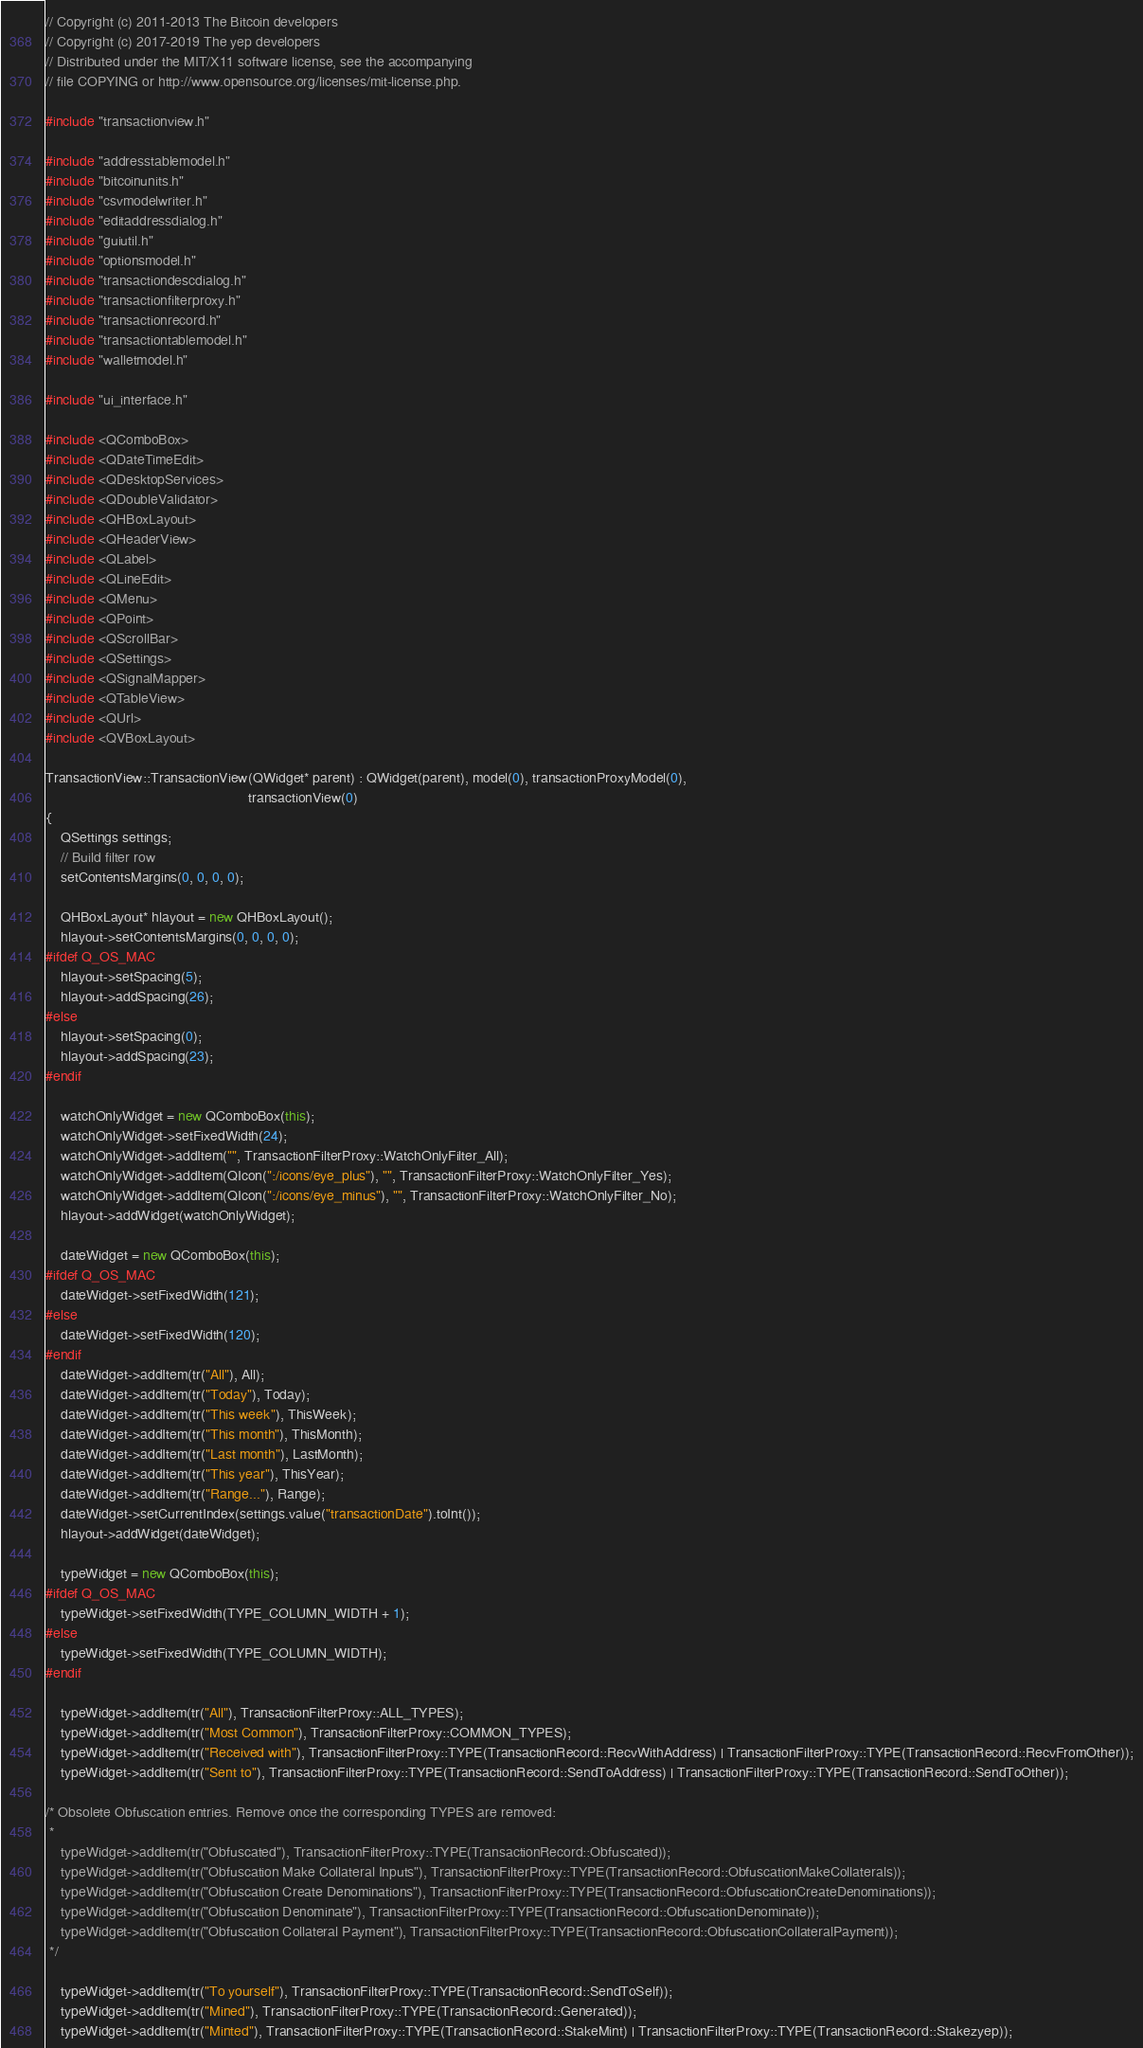<code> <loc_0><loc_0><loc_500><loc_500><_C++_>// Copyright (c) 2011-2013 The Bitcoin developers
// Copyright (c) 2017-2019 The yep developers
// Distributed under the MIT/X11 software license, see the accompanying
// file COPYING or http://www.opensource.org/licenses/mit-license.php.

#include "transactionview.h"

#include "addresstablemodel.h"
#include "bitcoinunits.h"
#include "csvmodelwriter.h"
#include "editaddressdialog.h"
#include "guiutil.h"
#include "optionsmodel.h"
#include "transactiondescdialog.h"
#include "transactionfilterproxy.h"
#include "transactionrecord.h"
#include "transactiontablemodel.h"
#include "walletmodel.h"

#include "ui_interface.h"

#include <QComboBox>
#include <QDateTimeEdit>
#include <QDesktopServices>
#include <QDoubleValidator>
#include <QHBoxLayout>
#include <QHeaderView>
#include <QLabel>
#include <QLineEdit>
#include <QMenu>
#include <QPoint>
#include <QScrollBar>
#include <QSettings>
#include <QSignalMapper>
#include <QTableView>
#include <QUrl>
#include <QVBoxLayout>

TransactionView::TransactionView(QWidget* parent) : QWidget(parent), model(0), transactionProxyModel(0),
                                                    transactionView(0)
{
    QSettings settings;
    // Build filter row
    setContentsMargins(0, 0, 0, 0);

    QHBoxLayout* hlayout = new QHBoxLayout();
    hlayout->setContentsMargins(0, 0, 0, 0);
#ifdef Q_OS_MAC
    hlayout->setSpacing(5);
    hlayout->addSpacing(26);
#else
    hlayout->setSpacing(0);
    hlayout->addSpacing(23);
#endif

    watchOnlyWidget = new QComboBox(this);
    watchOnlyWidget->setFixedWidth(24);
    watchOnlyWidget->addItem("", TransactionFilterProxy::WatchOnlyFilter_All);
    watchOnlyWidget->addItem(QIcon(":/icons/eye_plus"), "", TransactionFilterProxy::WatchOnlyFilter_Yes);
    watchOnlyWidget->addItem(QIcon(":/icons/eye_minus"), "", TransactionFilterProxy::WatchOnlyFilter_No);
    hlayout->addWidget(watchOnlyWidget);

    dateWidget = new QComboBox(this);
#ifdef Q_OS_MAC
    dateWidget->setFixedWidth(121);
#else
    dateWidget->setFixedWidth(120);
#endif
    dateWidget->addItem(tr("All"), All);
    dateWidget->addItem(tr("Today"), Today);
    dateWidget->addItem(tr("This week"), ThisWeek);
    dateWidget->addItem(tr("This month"), ThisMonth);
    dateWidget->addItem(tr("Last month"), LastMonth);
    dateWidget->addItem(tr("This year"), ThisYear);
    dateWidget->addItem(tr("Range..."), Range);
    dateWidget->setCurrentIndex(settings.value("transactionDate").toInt());
    hlayout->addWidget(dateWidget);

    typeWidget = new QComboBox(this);
#ifdef Q_OS_MAC
    typeWidget->setFixedWidth(TYPE_COLUMN_WIDTH + 1);
#else
    typeWidget->setFixedWidth(TYPE_COLUMN_WIDTH);
#endif

    typeWidget->addItem(tr("All"), TransactionFilterProxy::ALL_TYPES);
    typeWidget->addItem(tr("Most Common"), TransactionFilterProxy::COMMON_TYPES);
    typeWidget->addItem(tr("Received with"), TransactionFilterProxy::TYPE(TransactionRecord::RecvWithAddress) | TransactionFilterProxy::TYPE(TransactionRecord::RecvFromOther));
    typeWidget->addItem(tr("Sent to"), TransactionFilterProxy::TYPE(TransactionRecord::SendToAddress) | TransactionFilterProxy::TYPE(TransactionRecord::SendToOther));

/* Obsolete Obfuscation entries. Remove once the corresponding TYPES are removed:
 *
    typeWidget->addItem(tr("Obfuscated"), TransactionFilterProxy::TYPE(TransactionRecord::Obfuscated));
    typeWidget->addItem(tr("Obfuscation Make Collateral Inputs"), TransactionFilterProxy::TYPE(TransactionRecord::ObfuscationMakeCollaterals));
    typeWidget->addItem(tr("Obfuscation Create Denominations"), TransactionFilterProxy::TYPE(TransactionRecord::ObfuscationCreateDenominations));
    typeWidget->addItem(tr("Obfuscation Denominate"), TransactionFilterProxy::TYPE(TransactionRecord::ObfuscationDenominate));
    typeWidget->addItem(tr("Obfuscation Collateral Payment"), TransactionFilterProxy::TYPE(TransactionRecord::ObfuscationCollateralPayment));
 */

    typeWidget->addItem(tr("To yourself"), TransactionFilterProxy::TYPE(TransactionRecord::SendToSelf));
    typeWidget->addItem(tr("Mined"), TransactionFilterProxy::TYPE(TransactionRecord::Generated));
    typeWidget->addItem(tr("Minted"), TransactionFilterProxy::TYPE(TransactionRecord::StakeMint) | TransactionFilterProxy::TYPE(TransactionRecord::Stakezyep));</code> 